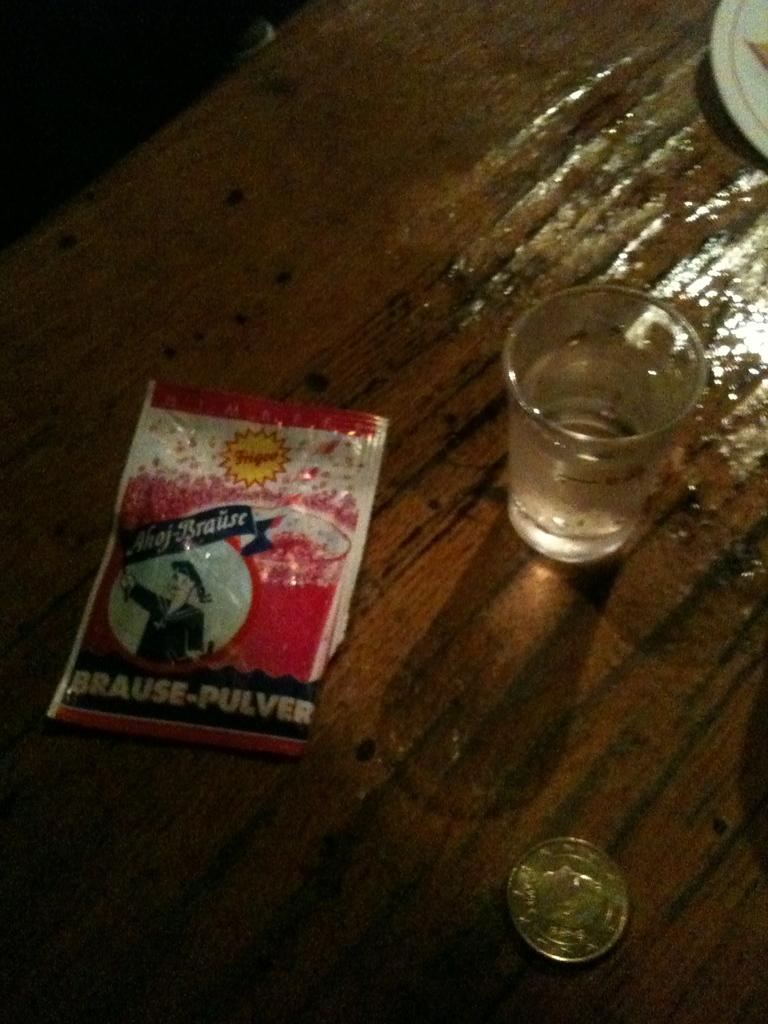<image>
Present a compact description of the photo's key features. A shot glass and a coin are next to a drink mix package saying brause-pulver. 